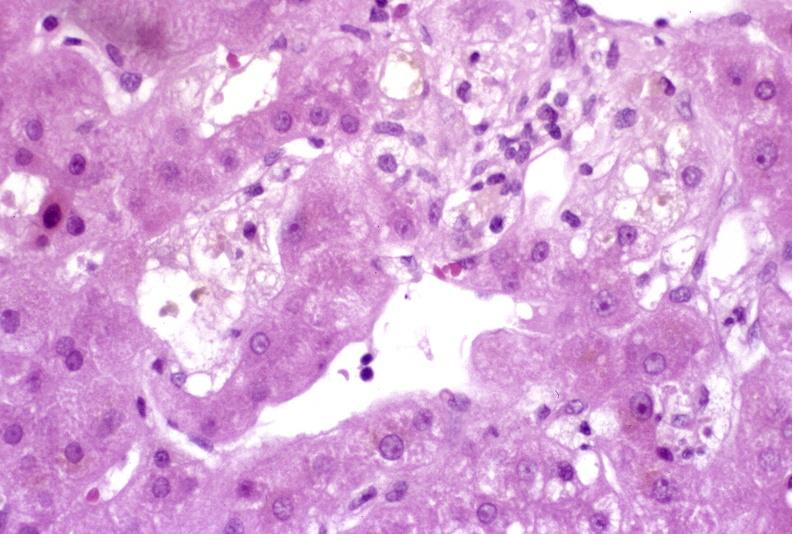what does this image show?
Answer the question using a single word or phrase. Recovery of ducts 